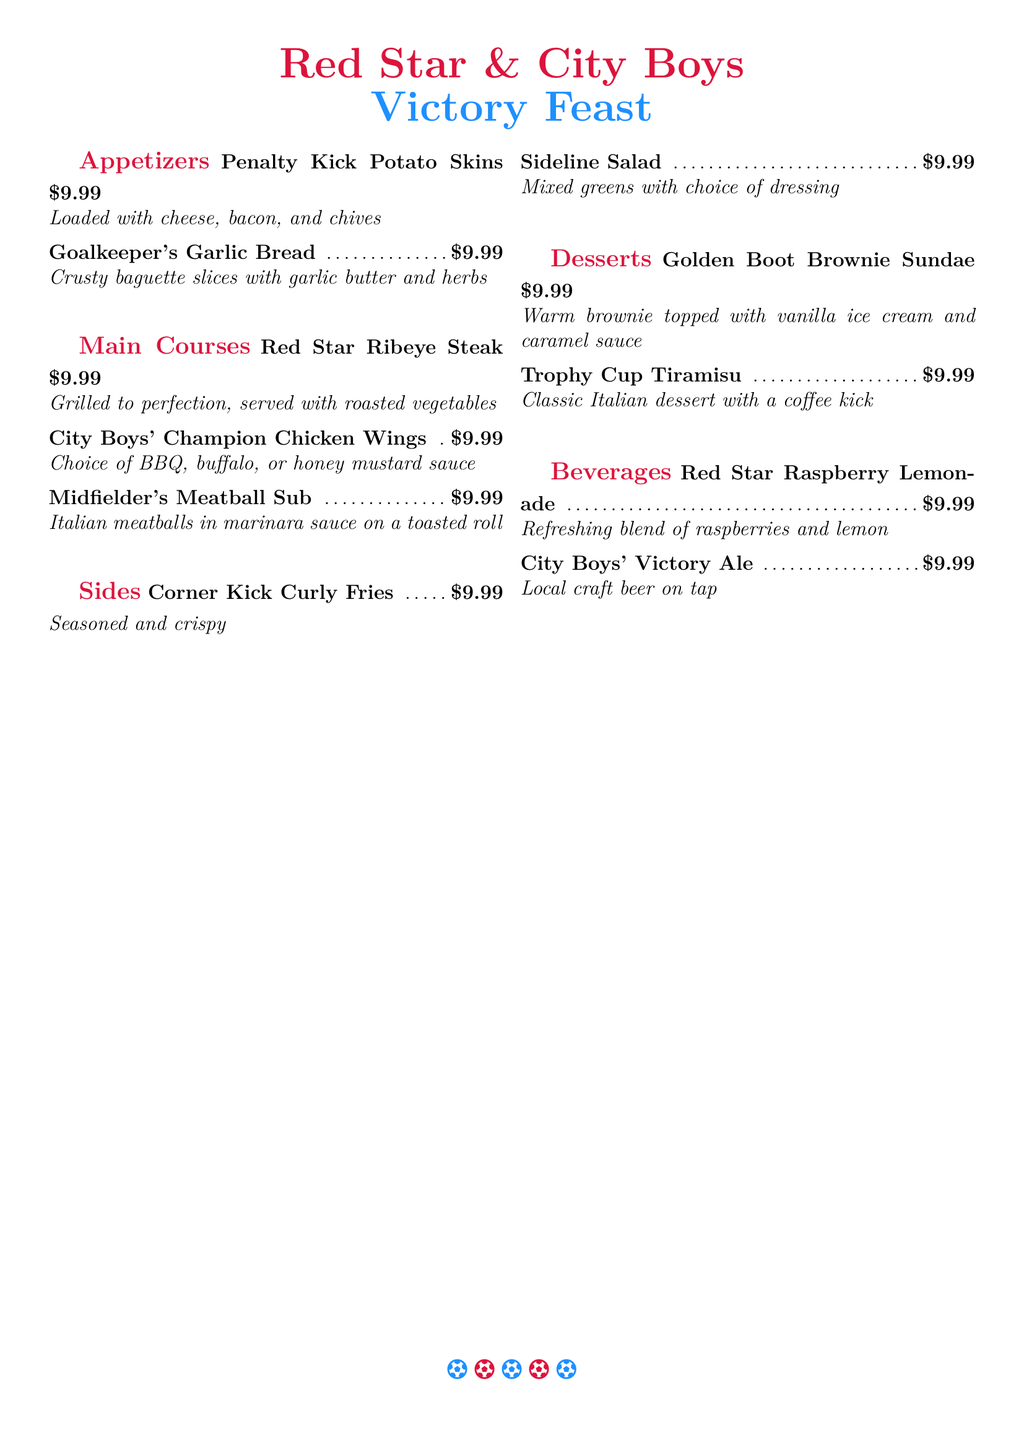What is the name of the dessert with a coffee kick? The dessert with a coffee kick is called "Trophy Cup Tiramisu."
Answer: Trophy Cup Tiramisu How much does each menu item cost? All menu items are priced at $9.99.
Answer: $9.99 What type of beverage is served on tap? The beverage served on tap is "City Boys' Victory Ale."
Answer: City Boys' Victory Ale What is included in the "Penalty Kick Potato Skins"? The "Penalty Kick Potato Skins" are loaded with cheese, bacon, and chives.
Answer: Cheese, bacon, and chives Which appetizer features garlic butter? The appetizer featuring garlic butter is "Goalkeeper's Garlic Bread."
Answer: Goalkeeper's Garlic Bread What is the main ingredient in the "Midfielder's Meatball Sub"? The main ingredient in the "Midfielder's Meatball Sub" is Italian meatballs.
Answer: Italian meatballs How many sections are there on the menu? The menu has five sections: Appetizers, Main Courses, Sides, Desserts, Beverages.
Answer: Five What type of salad is offered as a side? The side offered is "Sideline Salad."
Answer: Sideline Salad Which dessert is topped with vanilla ice cream? The dessert topped with vanilla ice cream is "Golden Boot Brownie Sundae."
Answer: Golden Boot Brownie Sundae 